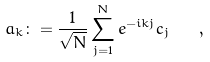Convert formula to latex. <formula><loc_0><loc_0><loc_500><loc_500>a _ { k } \colon = \frac { 1 } { \sqrt { N } } \sum _ { j = 1 } ^ { N } e ^ { - i k j } c _ { j } \quad ,</formula> 